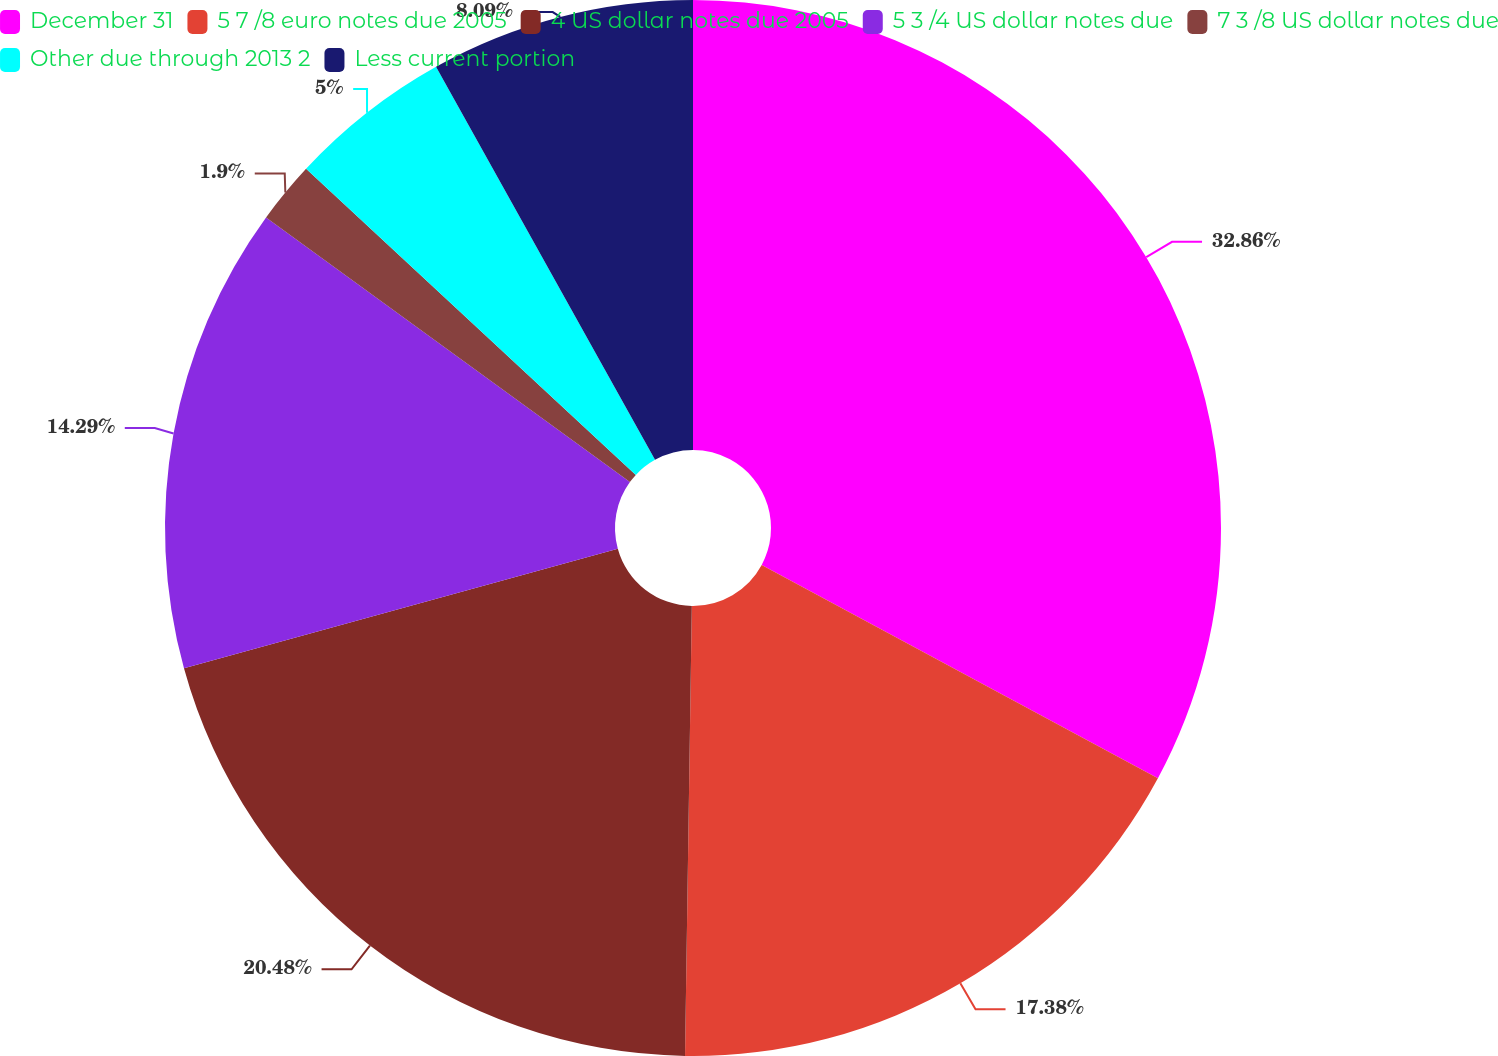Convert chart to OTSL. <chart><loc_0><loc_0><loc_500><loc_500><pie_chart><fcel>December 31<fcel>5 7 /8 euro notes due 2005<fcel>4 US dollar notes due 2005<fcel>5 3 /4 US dollar notes due<fcel>7 3 /8 US dollar notes due<fcel>Other due through 2013 2<fcel>Less current portion<nl><fcel>32.86%<fcel>17.38%<fcel>20.48%<fcel>14.29%<fcel>1.9%<fcel>5.0%<fcel>8.09%<nl></chart> 